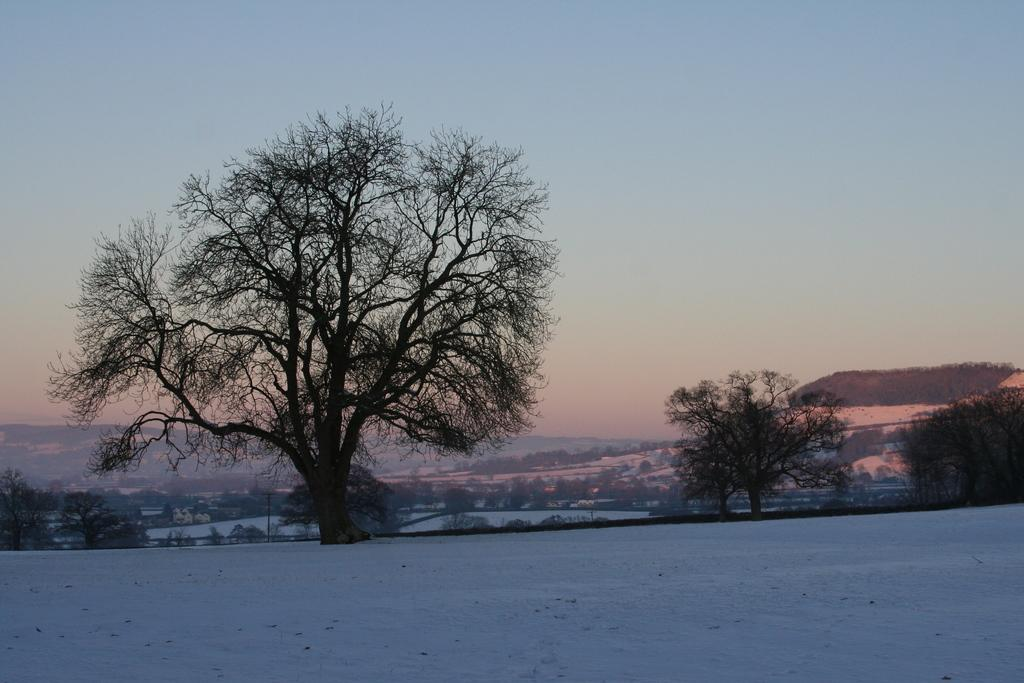What type of natural environment is depicted in the image? The image shows a snowy landscape with trees and mountains. Where are the trees located in the image? The trees are in the center of the image. What can be seen at the bottom of the image? There is snow and mountains at the bottom of the image. What part of the natural environment is visible in the image? The sky is visible in the image. What type of pickle is being used to build the snowman in the image? There is no pickle present in the image, and no snowman is being built. 